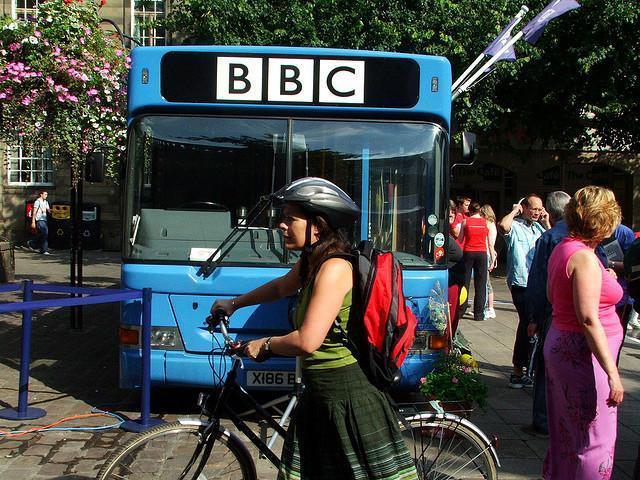How many people are in the picture?
Give a very brief answer. 5. 